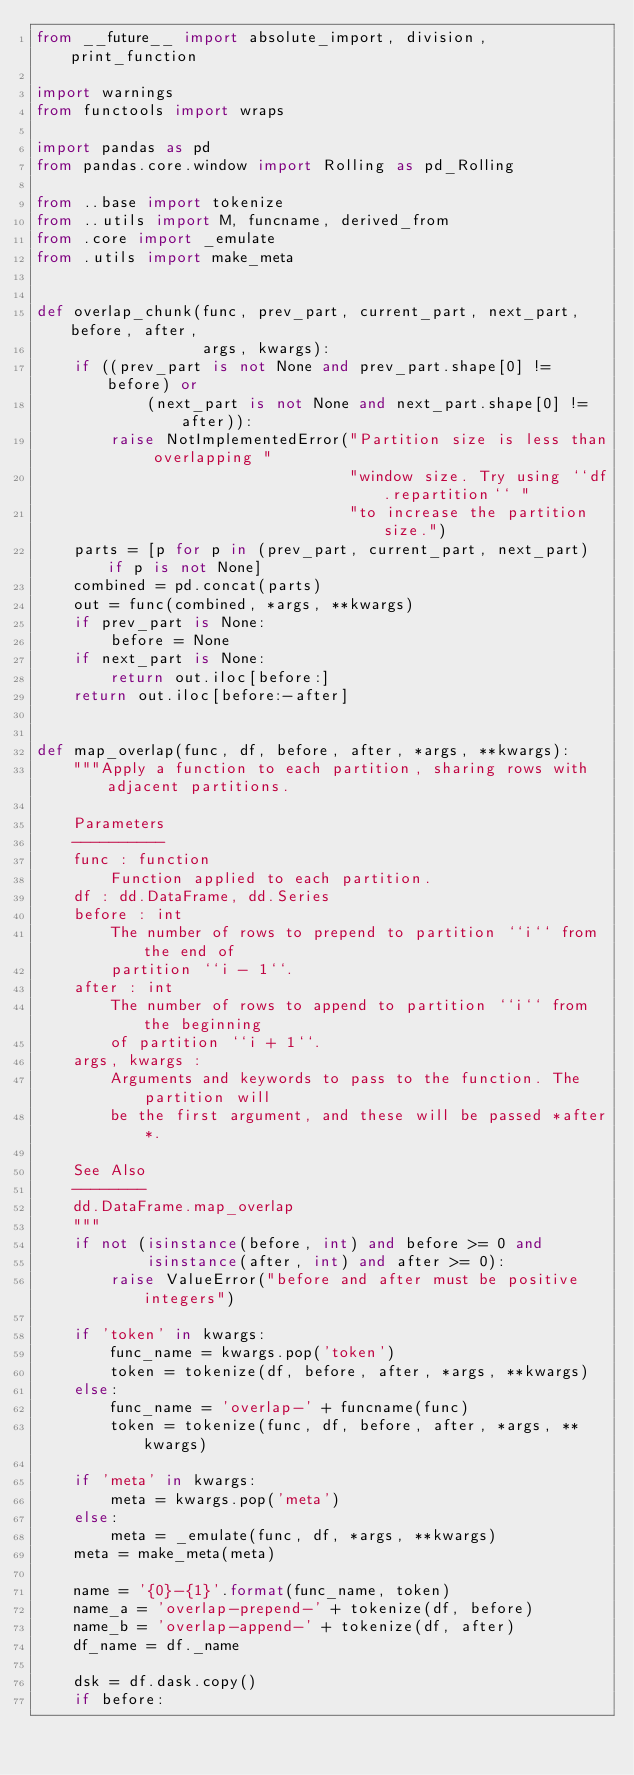<code> <loc_0><loc_0><loc_500><loc_500><_Python_>from __future__ import absolute_import, division, print_function

import warnings
from functools import wraps

import pandas as pd
from pandas.core.window import Rolling as pd_Rolling

from ..base import tokenize
from ..utils import M, funcname, derived_from
from .core import _emulate
from .utils import make_meta


def overlap_chunk(func, prev_part, current_part, next_part, before, after,
                  args, kwargs):
    if ((prev_part is not None and prev_part.shape[0] != before) or
            (next_part is not None and next_part.shape[0] != after)):
        raise NotImplementedError("Partition size is less than overlapping "
                                  "window size. Try using ``df.repartition`` "
                                  "to increase the partition size.")
    parts = [p for p in (prev_part, current_part, next_part) if p is not None]
    combined = pd.concat(parts)
    out = func(combined, *args, **kwargs)
    if prev_part is None:
        before = None
    if next_part is None:
        return out.iloc[before:]
    return out.iloc[before:-after]


def map_overlap(func, df, before, after, *args, **kwargs):
    """Apply a function to each partition, sharing rows with adjacent partitions.

    Parameters
    ----------
    func : function
        Function applied to each partition.
    df : dd.DataFrame, dd.Series
    before : int
        The number of rows to prepend to partition ``i`` from the end of
        partition ``i - 1``.
    after : int
        The number of rows to append to partition ``i`` from the beginning
        of partition ``i + 1``.
    args, kwargs :
        Arguments and keywords to pass to the function. The partition will
        be the first argument, and these will be passed *after*.

    See Also
    --------
    dd.DataFrame.map_overlap
    """
    if not (isinstance(before, int) and before >= 0 and
            isinstance(after, int) and after >= 0):
        raise ValueError("before and after must be positive integers")

    if 'token' in kwargs:
        func_name = kwargs.pop('token')
        token = tokenize(df, before, after, *args, **kwargs)
    else:
        func_name = 'overlap-' + funcname(func)
        token = tokenize(func, df, before, after, *args, **kwargs)

    if 'meta' in kwargs:
        meta = kwargs.pop('meta')
    else:
        meta = _emulate(func, df, *args, **kwargs)
    meta = make_meta(meta)

    name = '{0}-{1}'.format(func_name, token)
    name_a = 'overlap-prepend-' + tokenize(df, before)
    name_b = 'overlap-append-' + tokenize(df, after)
    df_name = df._name

    dsk = df.dask.copy()
    if before:</code> 